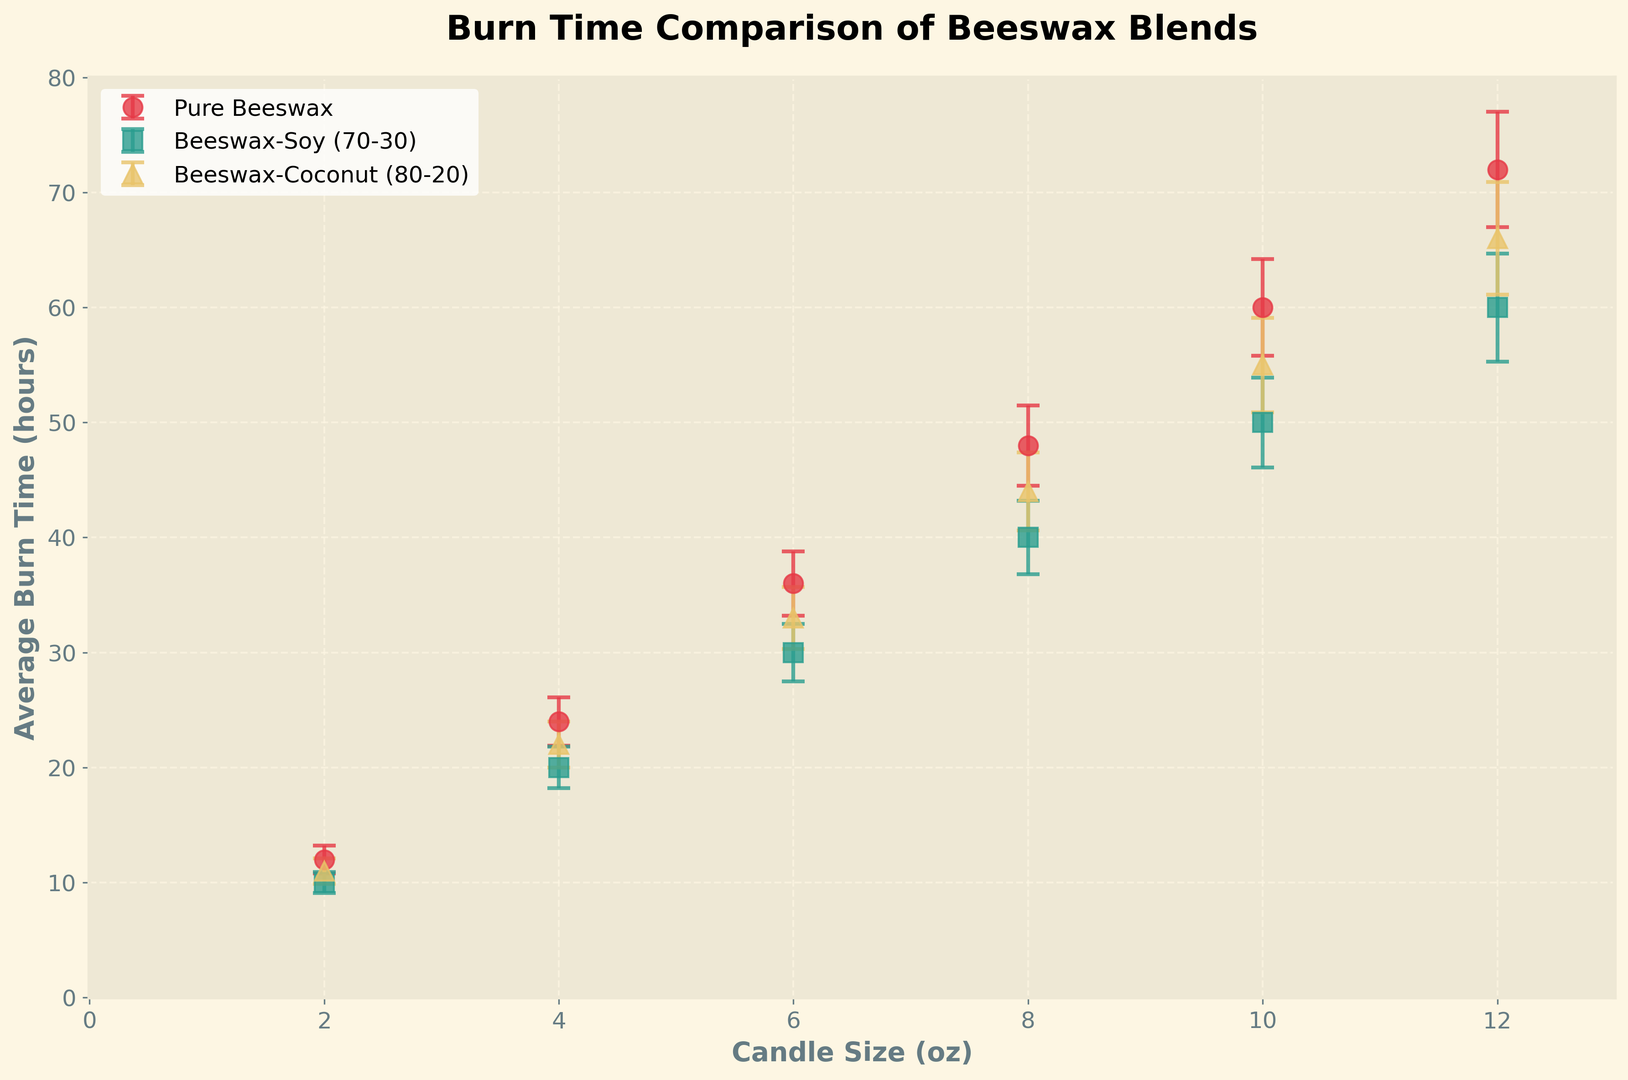What's the candle size with the highest average burn time for the Pure Beeswax blend? Look for the highest data point on the `Pure Beeswax` line. It's at the 12 oz candle size with an average burn time of 72 hours.
Answer: 12 oz Which blend has the lowest average burn time for the 6 oz candle size? Compare the burn times for all three blends at the 6 oz candle size. `Beeswax-Soy (70-30)` has 30 hours, which is the lowest among the blends.
Answer: Beeswax-Soy (70-30) How does the burn time of the 8 oz Pure Beeswax candle compare to the 8 oz Beeswax-Coconut (80-20) candle? Check the y-values for `8 oz` on both `Pure Beeswax` and `Beeswax-Coconut (80-20)` lines. `Pure Beeswax` has 48 hours, and `Beeswax-Coconut (80-20)` has 44 hours. The Pure Beeswax candle burns longer.
Answer: Pure Beeswax burns longer What is the average burn time difference between the 4 oz Pure Beeswax and Beeswax-Soy (70-30) candles? Look at the y-values for `4 oz`. The `Pure Beeswax` is 24 hours and `Beeswax-Soy (70-30)` is 20 hours. The difference is 24 - 20 = 4 hours.
Answer: 4 hours Which blend shows the most variability in burn time for the 12 oz candle? Compare the error bars for `12 oz`. The `Pure Beeswax` has an error bar of 5 hours, `Beeswax-Soy (70-30)` has 4.7 hours, and `Beeswax-Coconut (80-20)` has 4.9 hours. The `Pure Beeswax` blend shows the most variability.
Answer: Pure Beeswax What is the total average burn time for all blends at the 10 oz candle size? Sum the y-values for `10 oz`. `Pure Beeswax` is 60 hours, `Beeswax-Soy (70-30)` is 50 hours, and `Beeswax-Coconut (80-20)` is 55 hours. The total is 60 + 50 + 55 = 165 hours.
Answer: 165 hours Between which candle sizes does the average burn time for Beeswax-Coconut (80-20) increase the most? Observe the increase in y-values between consecutive candle sizes for `Beeswax-Coconut (80-20)`. The largest increase is between `10 oz` (55 hours) and `12 oz` (66 hours), resulting in an 11-hour increase.
Answer: Between 10 oz and 12 oz Is there a candle size where all three blends have the same burn time? Scan through the x-axis corresponding to all candle sizes and compare the y-values of all three blends at each size. No single candle size shows equal burn time across all three blends.
Answer: No 